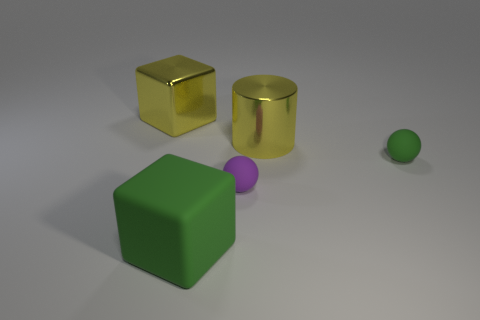Add 5 large objects. How many objects exist? 10 Subtract all cubes. How many objects are left? 3 Subtract all large red balls. Subtract all tiny green spheres. How many objects are left? 4 Add 1 yellow blocks. How many yellow blocks are left? 2 Add 3 tiny matte objects. How many tiny matte objects exist? 5 Subtract 0 gray balls. How many objects are left? 5 